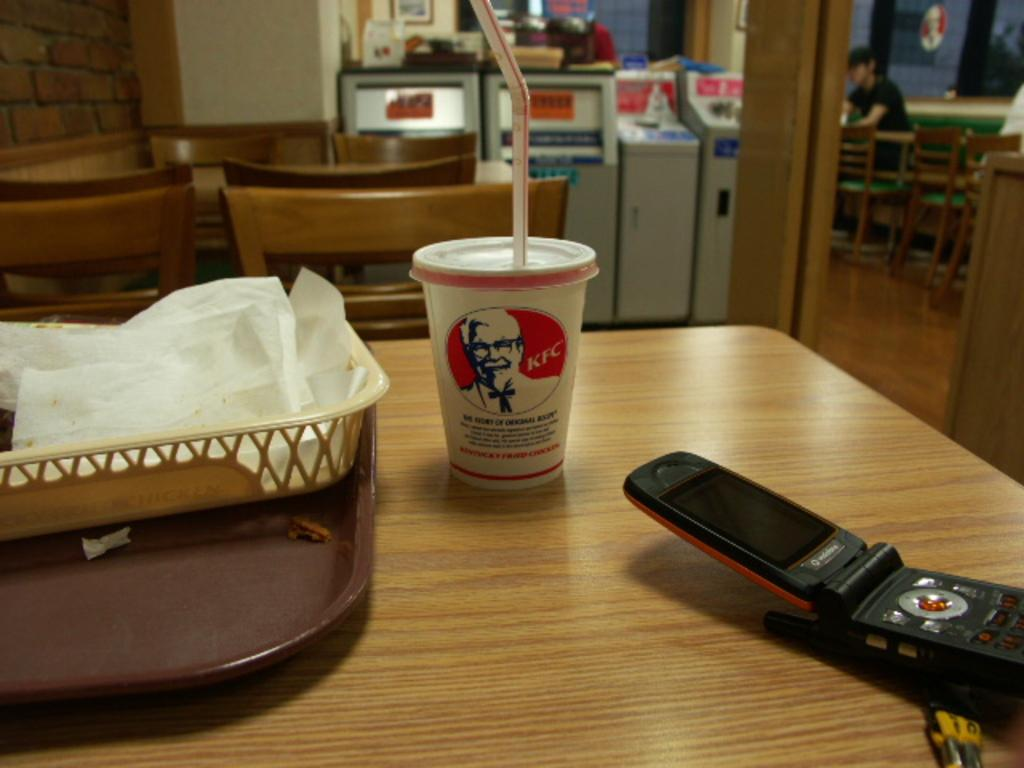What is on the table in the image? There is a juice glass, a mobile phone, and a basket with tissue papers on the table. What else can be seen on the table? There is nothing else visible on the table besides the mentioned items. What type of furniture is present in the image? There are chairs in the image. Is anyone sitting on the chairs? Yes, there is a person is sitting on one of the chairs. What thought is the person having while sitting on the chair in the image? There is no way to determine the person's thoughts from the image. Is there a letter on the table in the image? No, there is no letter present on the table in the image. 